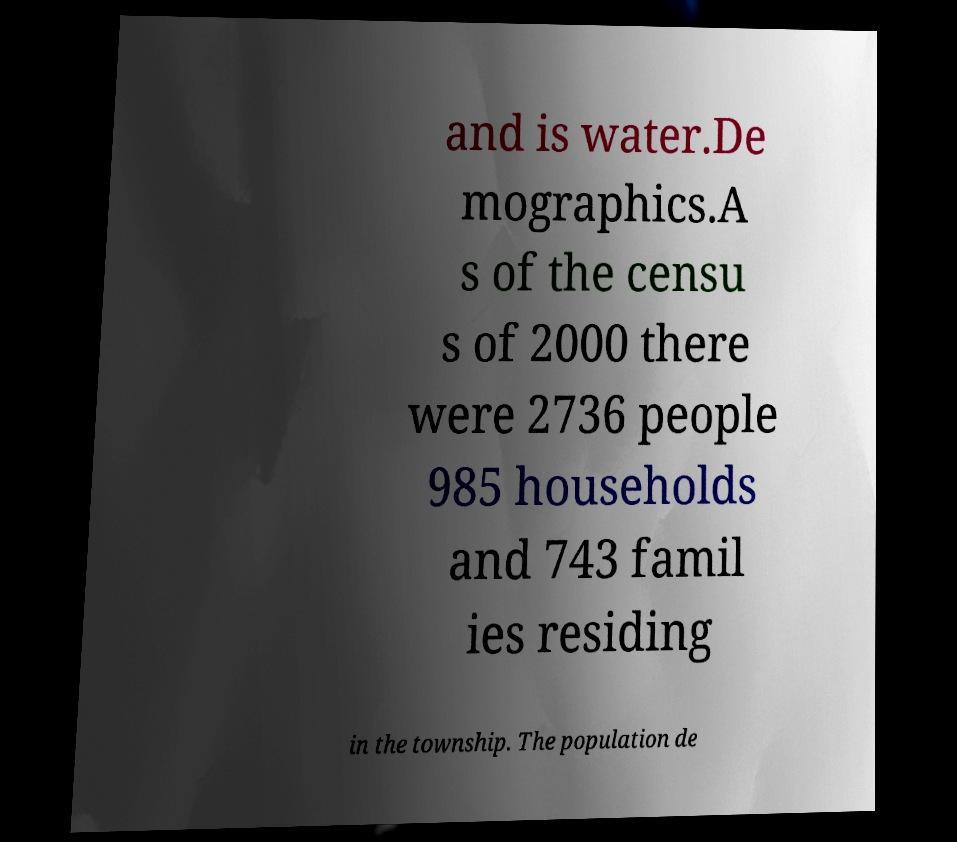Could you assist in decoding the text presented in this image and type it out clearly? and is water.De mographics.A s of the censu s of 2000 there were 2736 people 985 households and 743 famil ies residing in the township. The population de 